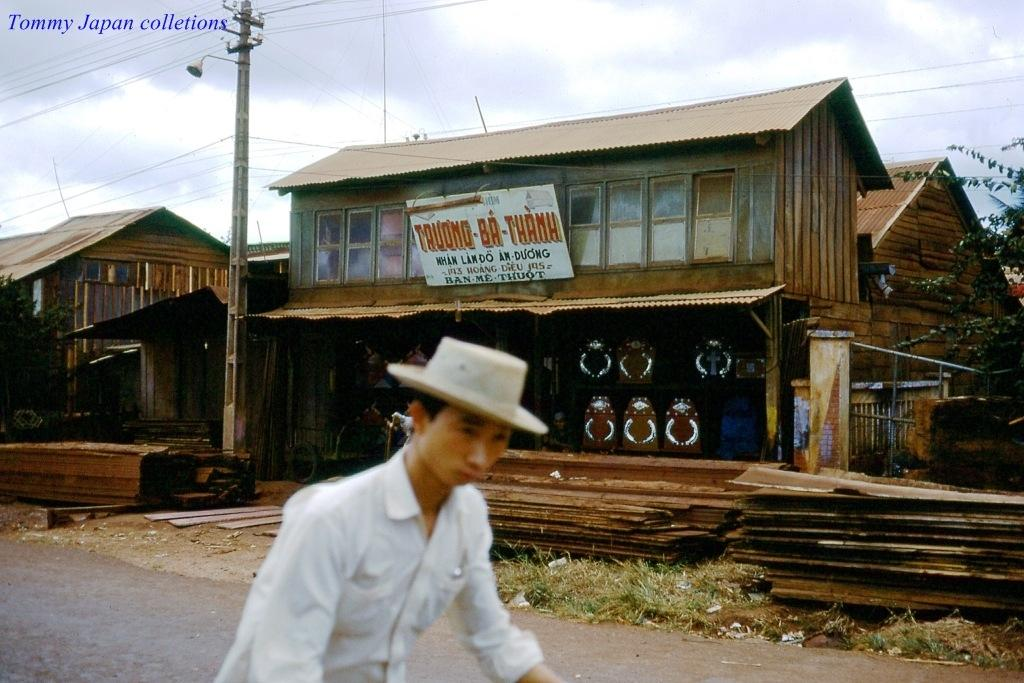What type of structure can be seen in the image? There is an electrical pole in the image. What other object related to electricity can be seen? There is a street light in the image. Is there a person present in the image? Yes, there is a person in the image. What is the person wearing on their head? The person is wearing a hat. What type of building can be seen in the background? There is a house in the background of the image. Can you see any boats in the image? No, there are no boats present in the image. What type of twig is being used by the person in the image? There is no twig visible in the image; the person is wearing a hat. 